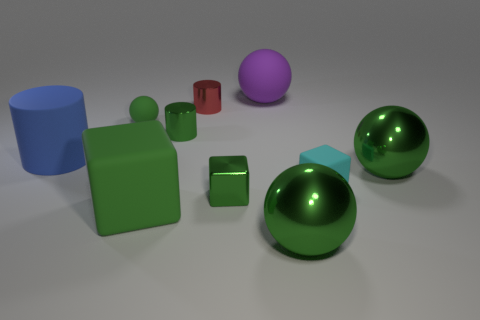There is a green ball that is the same material as the small cyan object; what size is it?
Give a very brief answer. Small. How many yellow objects are tiny matte balls or metal cubes?
Offer a very short reply. 0. Are there any purple things of the same size as the cyan matte thing?
Make the answer very short. No. What is the material of the cyan cube that is the same size as the red thing?
Your response must be concise. Rubber. There is a green ball that is left of the red cylinder; does it have the same size as the block left of the small green metallic cylinder?
Provide a succinct answer. No. What number of things are either big purple things or big metal spheres that are to the right of the cyan block?
Your response must be concise. 2. Are there any other shiny objects that have the same shape as the blue object?
Provide a short and direct response. Yes. What is the size of the cyan object right of the green shiny thing that is behind the blue object?
Your answer should be compact. Small. Do the tiny rubber ball and the big block have the same color?
Your answer should be very brief. Yes. How many rubber objects are big red spheres or small cyan things?
Provide a short and direct response. 1. 